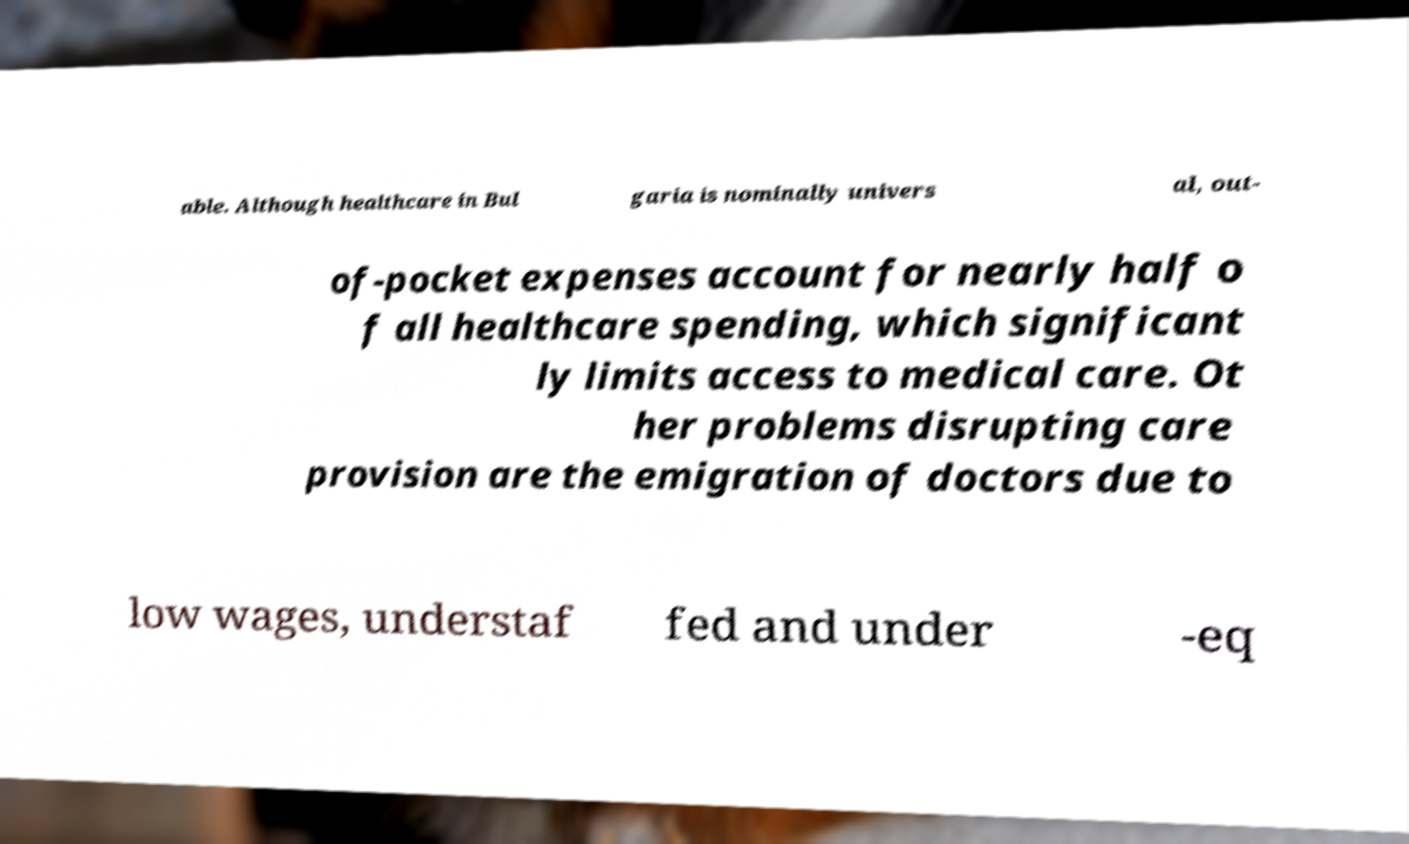There's text embedded in this image that I need extracted. Can you transcribe it verbatim? able. Although healthcare in Bul garia is nominally univers al, out- of-pocket expenses account for nearly half o f all healthcare spending, which significant ly limits access to medical care. Ot her problems disrupting care provision are the emigration of doctors due to low wages, understaf fed and under -eq 